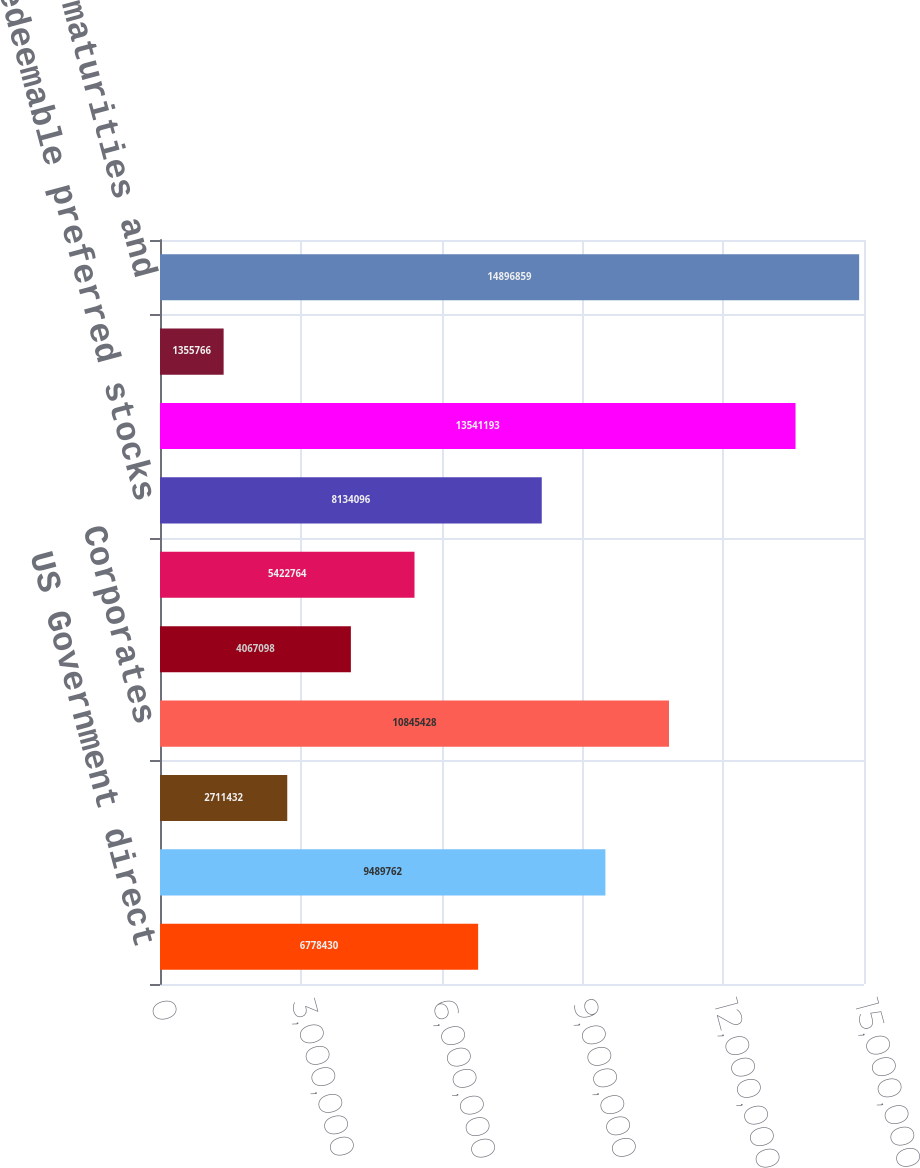Convert chart. <chart><loc_0><loc_0><loc_500><loc_500><bar_chart><fcel>US Government direct<fcel>States municipalities and<fcel>Foreign governments<fcel>Corporates<fcel>Collateralized debt<fcel>Other asset-backed securities<fcel>Redeemable preferred stocks<fcel>Total fixed maturities<fcel>Equity securities<fcel>Total fixed maturities and<nl><fcel>6.77843e+06<fcel>9.48976e+06<fcel>2.71143e+06<fcel>1.08454e+07<fcel>4.0671e+06<fcel>5.42276e+06<fcel>8.1341e+06<fcel>1.35412e+07<fcel>1.35577e+06<fcel>1.48969e+07<nl></chart> 